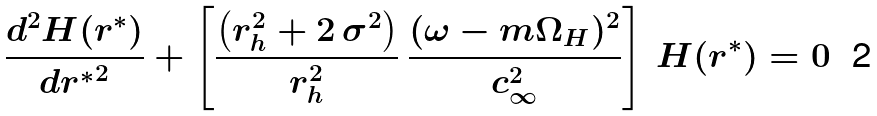Convert formula to latex. <formula><loc_0><loc_0><loc_500><loc_500>\frac { d ^ { 2 } H ( r ^ { * } ) } { d { r ^ { * } } ^ { 2 } } + \left [ \frac { \left ( r _ { h } ^ { 2 } + 2 \, { \sigma } ^ { 2 } \right ) } { r _ { h } ^ { 2 } } \, \frac { ( \omega - m \Omega _ { H } ) ^ { 2 } } { c ^ { 2 } _ { \infty } } \right ] \, H ( r ^ { * } ) = 0</formula> 